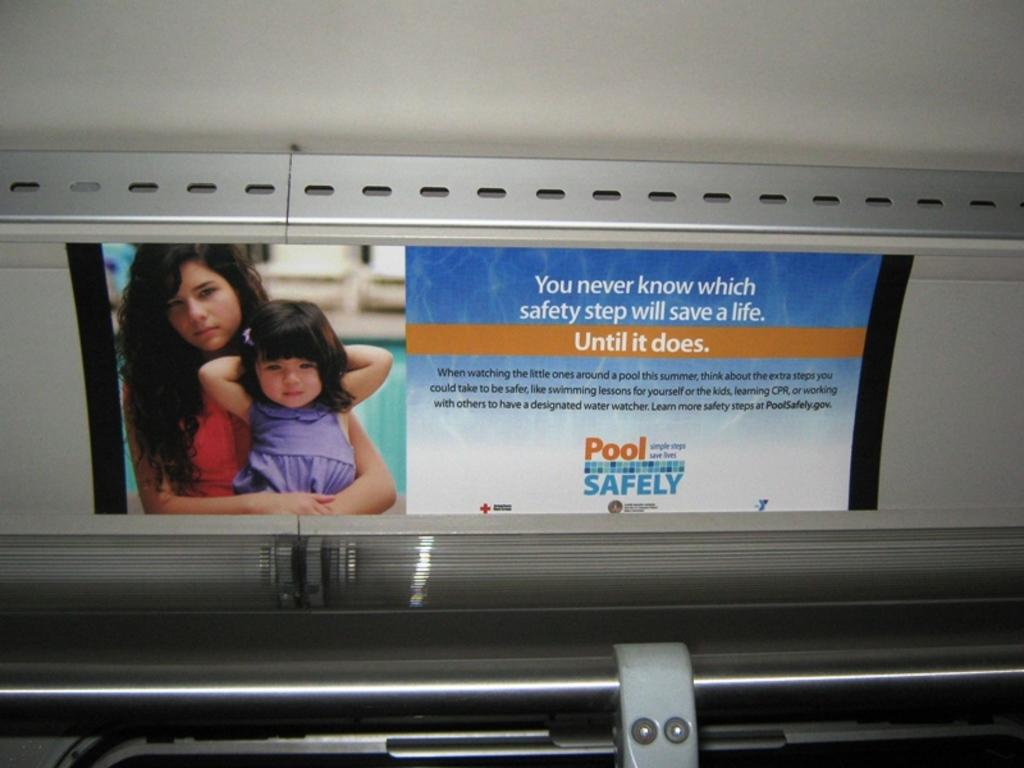What is the setting of the image? The image shows the inside of a vehicle. What can be seen on the interior walls of the vehicle? There is a poster inside the vehicle. How many goldfish are swimming in the vehicle's cup holder in the image? There are no goldfish present in the image; it only shows the inside of a vehicle with a poster on the wall. 